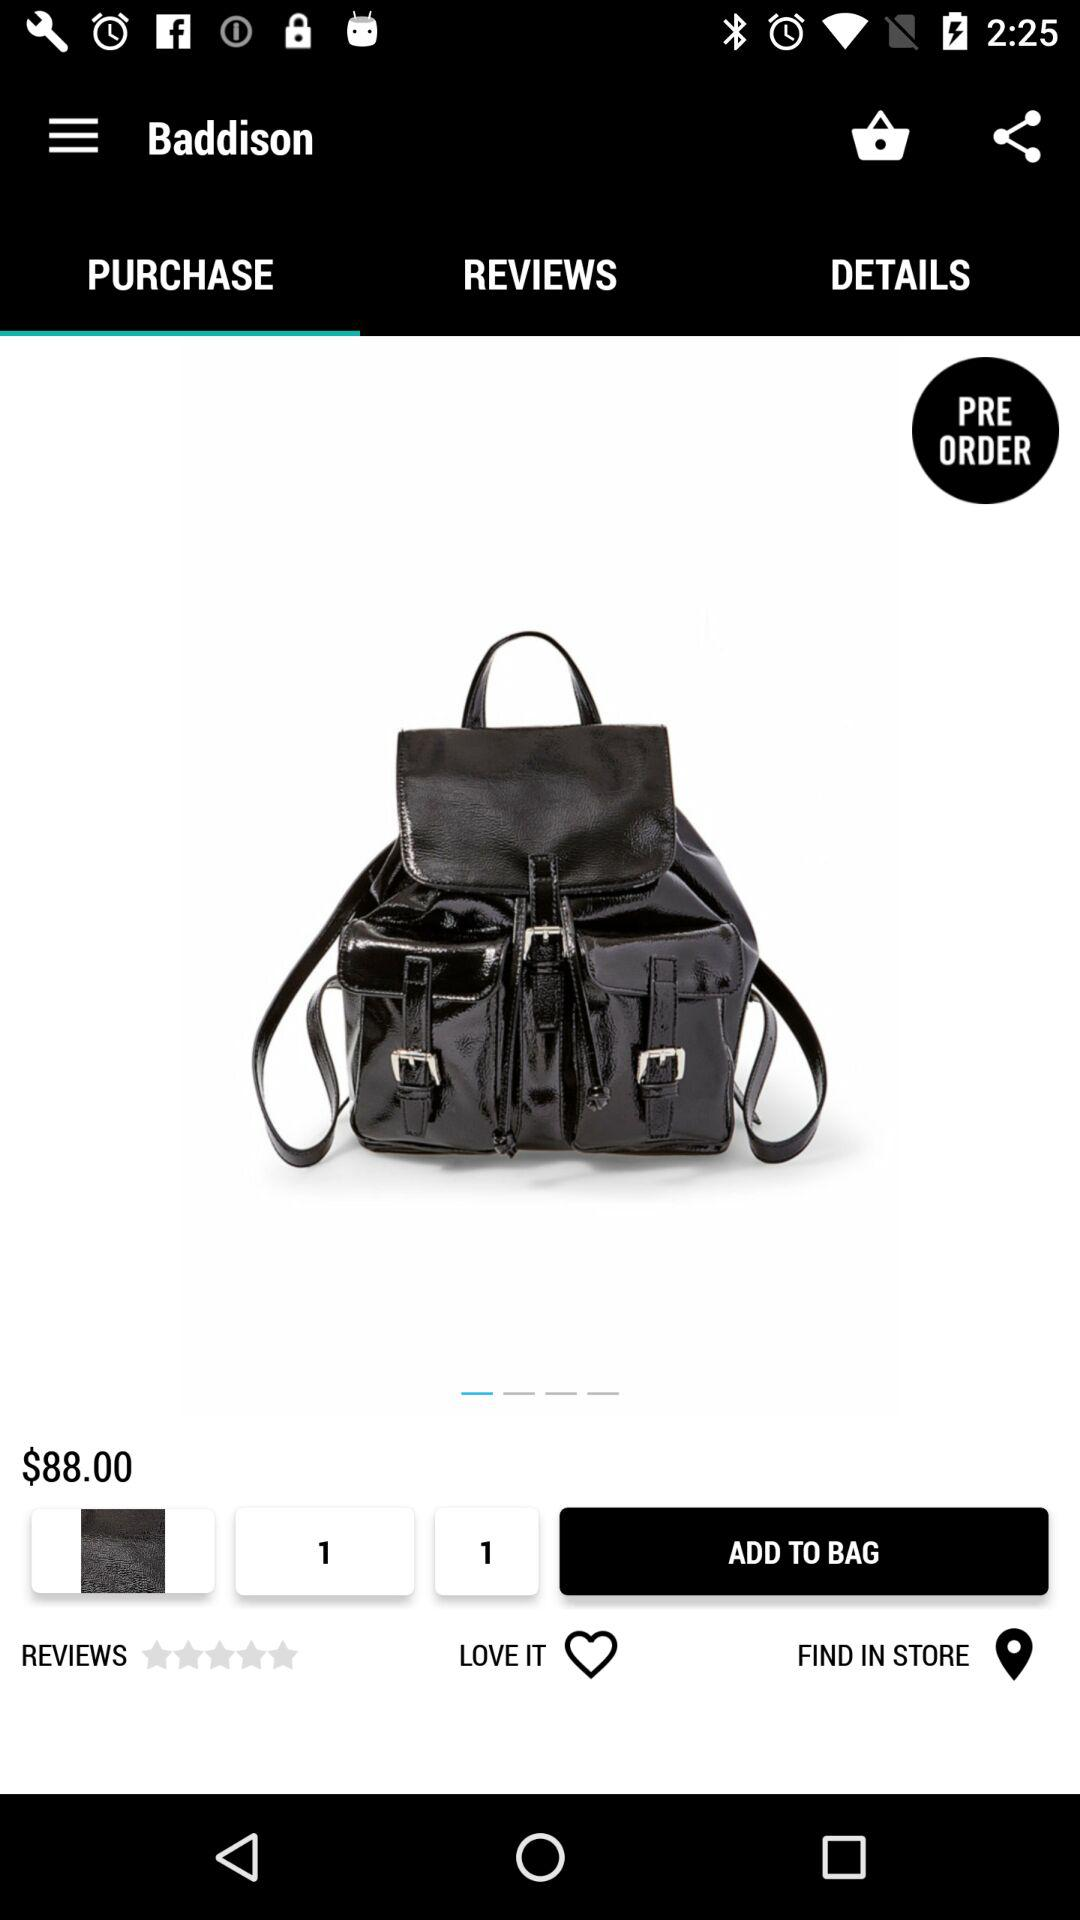How much is the backpack?
Answer the question using a single word or phrase. $88.00 